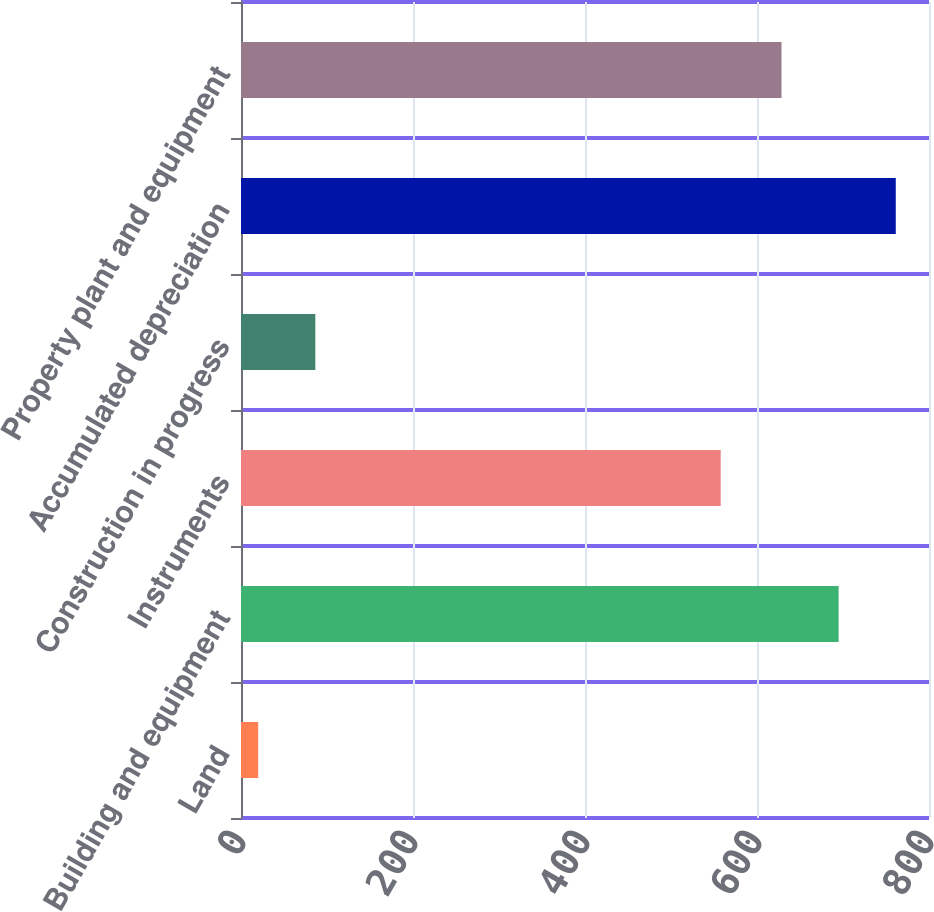<chart> <loc_0><loc_0><loc_500><loc_500><bar_chart><fcel>Land<fcel>Building and equipment<fcel>Instruments<fcel>Construction in progress<fcel>Accumulated depreciation<fcel>Property plant and equipment<nl><fcel>20<fcel>694.93<fcel>557.8<fcel>86.43<fcel>761.36<fcel>628.5<nl></chart> 